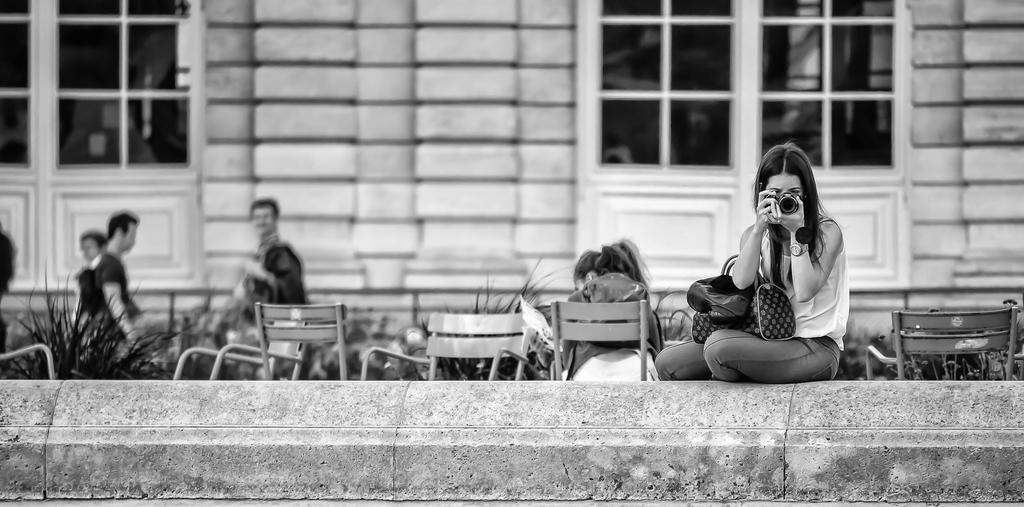Who is the main subject in the image? There is a lady in the image. What is the lady holding in the image? The lady is holding a camera. What architectural features can be seen in the image? There are doors visible in the image. What type of furniture is present in the image? Chairs are present in the image. Are there any other people in the image besides the lady? Yes, there are people in the image. What type of vegetation is visible in the image? Plants are visible in the image. How does the van shake in the image? There is no van present in the image, so it cannot shake. 